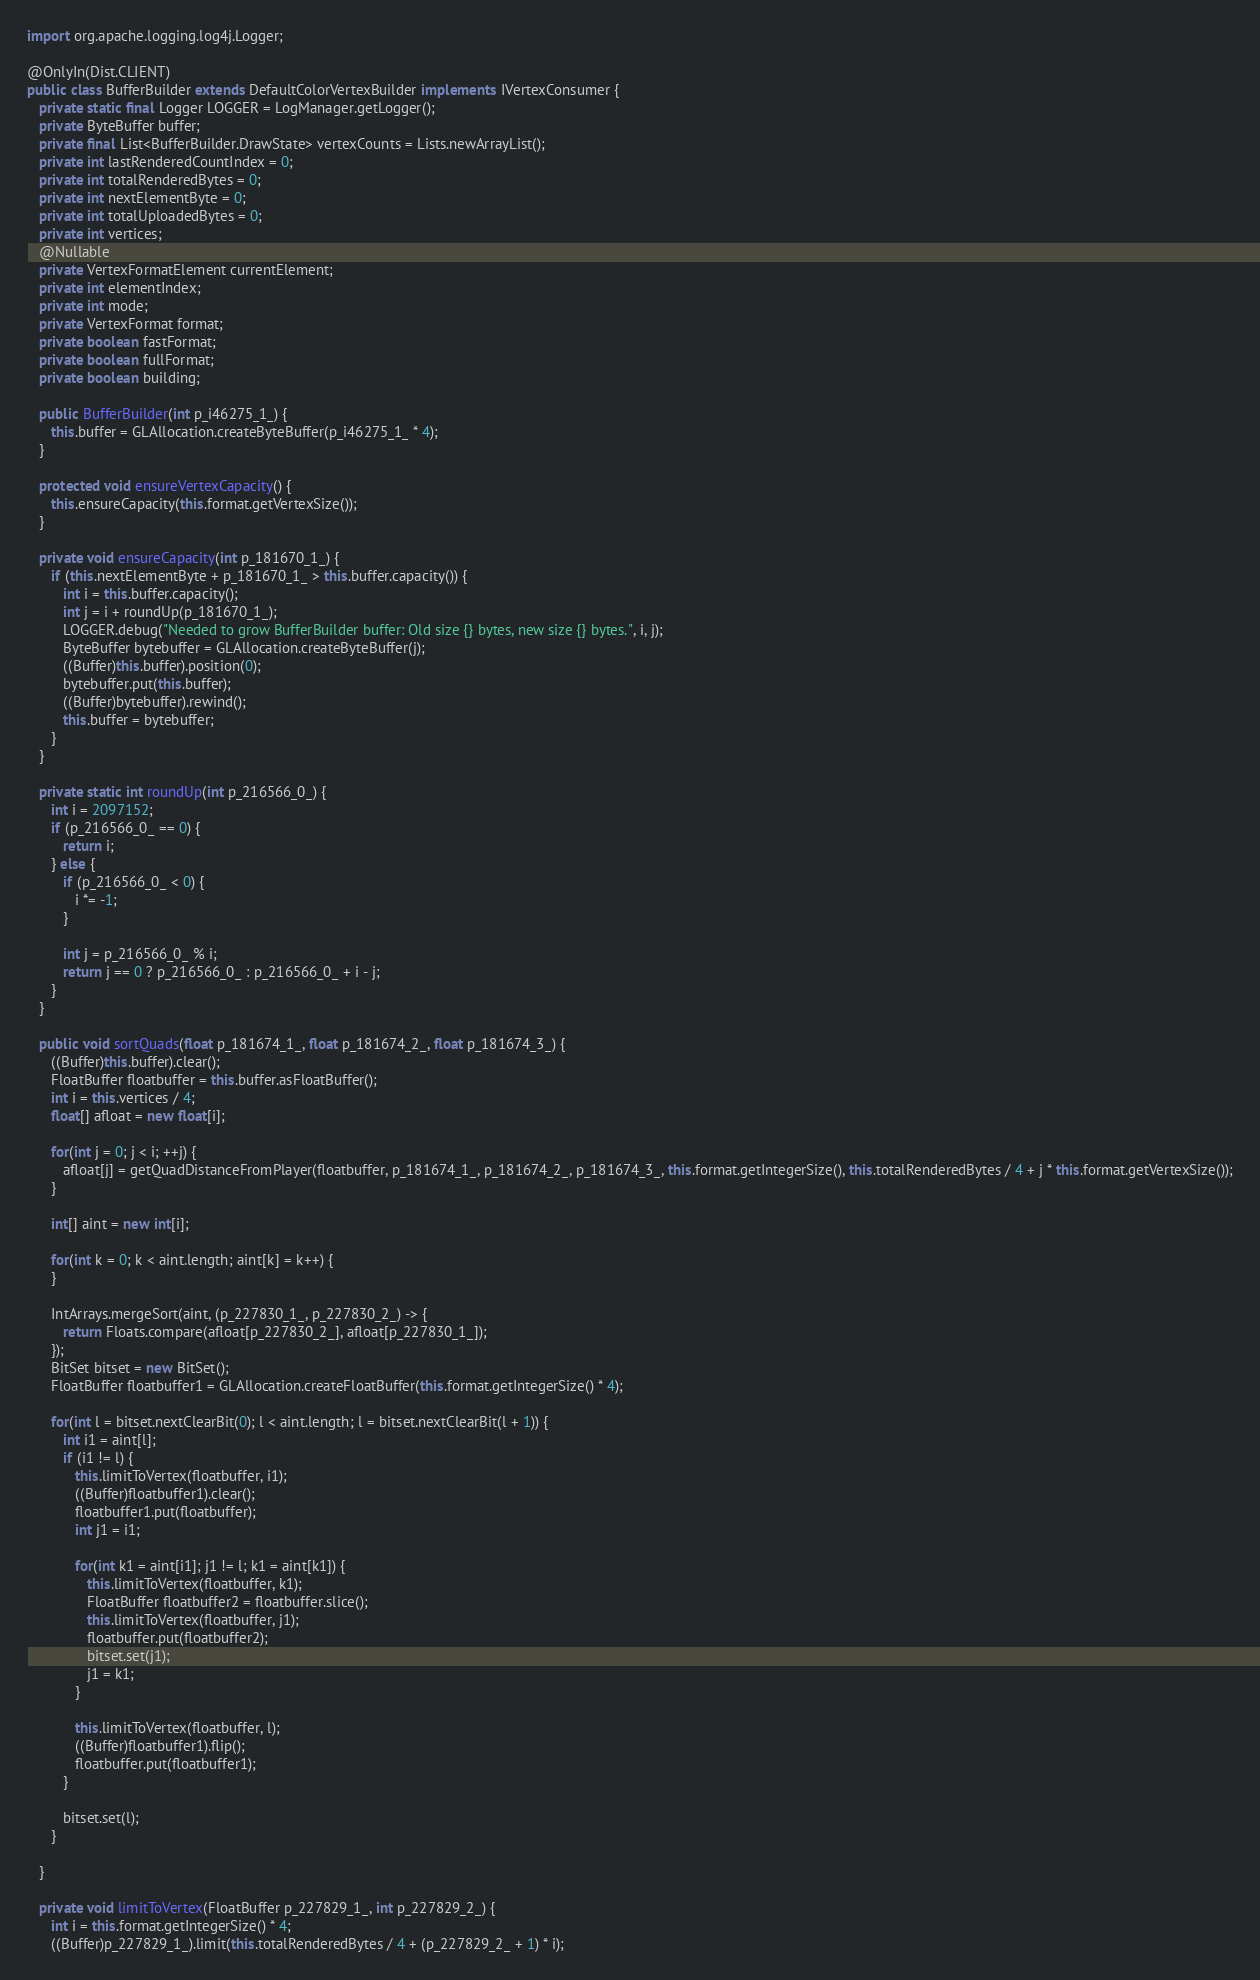<code> <loc_0><loc_0><loc_500><loc_500><_Java_>import org.apache.logging.log4j.Logger;

@OnlyIn(Dist.CLIENT)
public class BufferBuilder extends DefaultColorVertexBuilder implements IVertexConsumer {
   private static final Logger LOGGER = LogManager.getLogger();
   private ByteBuffer buffer;
   private final List<BufferBuilder.DrawState> vertexCounts = Lists.newArrayList();
   private int lastRenderedCountIndex = 0;
   private int totalRenderedBytes = 0;
   private int nextElementByte = 0;
   private int totalUploadedBytes = 0;
   private int vertices;
   @Nullable
   private VertexFormatElement currentElement;
   private int elementIndex;
   private int mode;
   private VertexFormat format;
   private boolean fastFormat;
   private boolean fullFormat;
   private boolean building;

   public BufferBuilder(int p_i46275_1_) {
      this.buffer = GLAllocation.createByteBuffer(p_i46275_1_ * 4);
   }

   protected void ensureVertexCapacity() {
      this.ensureCapacity(this.format.getVertexSize());
   }

   private void ensureCapacity(int p_181670_1_) {
      if (this.nextElementByte + p_181670_1_ > this.buffer.capacity()) {
         int i = this.buffer.capacity();
         int j = i + roundUp(p_181670_1_);
         LOGGER.debug("Needed to grow BufferBuilder buffer: Old size {} bytes, new size {} bytes.", i, j);
         ByteBuffer bytebuffer = GLAllocation.createByteBuffer(j);
         ((Buffer)this.buffer).position(0);
         bytebuffer.put(this.buffer);
         ((Buffer)bytebuffer).rewind();
         this.buffer = bytebuffer;
      }
   }

   private static int roundUp(int p_216566_0_) {
      int i = 2097152;
      if (p_216566_0_ == 0) {
         return i;
      } else {
         if (p_216566_0_ < 0) {
            i *= -1;
         }

         int j = p_216566_0_ % i;
         return j == 0 ? p_216566_0_ : p_216566_0_ + i - j;
      }
   }

   public void sortQuads(float p_181674_1_, float p_181674_2_, float p_181674_3_) {
      ((Buffer)this.buffer).clear();
      FloatBuffer floatbuffer = this.buffer.asFloatBuffer();
      int i = this.vertices / 4;
      float[] afloat = new float[i];

      for(int j = 0; j < i; ++j) {
         afloat[j] = getQuadDistanceFromPlayer(floatbuffer, p_181674_1_, p_181674_2_, p_181674_3_, this.format.getIntegerSize(), this.totalRenderedBytes / 4 + j * this.format.getVertexSize());
      }

      int[] aint = new int[i];

      for(int k = 0; k < aint.length; aint[k] = k++) {
      }

      IntArrays.mergeSort(aint, (p_227830_1_, p_227830_2_) -> {
         return Floats.compare(afloat[p_227830_2_], afloat[p_227830_1_]);
      });
      BitSet bitset = new BitSet();
      FloatBuffer floatbuffer1 = GLAllocation.createFloatBuffer(this.format.getIntegerSize() * 4);

      for(int l = bitset.nextClearBit(0); l < aint.length; l = bitset.nextClearBit(l + 1)) {
         int i1 = aint[l];
         if (i1 != l) {
            this.limitToVertex(floatbuffer, i1);
            ((Buffer)floatbuffer1).clear();
            floatbuffer1.put(floatbuffer);
            int j1 = i1;

            for(int k1 = aint[i1]; j1 != l; k1 = aint[k1]) {
               this.limitToVertex(floatbuffer, k1);
               FloatBuffer floatbuffer2 = floatbuffer.slice();
               this.limitToVertex(floatbuffer, j1);
               floatbuffer.put(floatbuffer2);
               bitset.set(j1);
               j1 = k1;
            }

            this.limitToVertex(floatbuffer, l);
            ((Buffer)floatbuffer1).flip();
            floatbuffer.put(floatbuffer1);
         }

         bitset.set(l);
      }

   }

   private void limitToVertex(FloatBuffer p_227829_1_, int p_227829_2_) {
      int i = this.format.getIntegerSize() * 4;
      ((Buffer)p_227829_1_).limit(this.totalRenderedBytes / 4 + (p_227829_2_ + 1) * i);</code> 